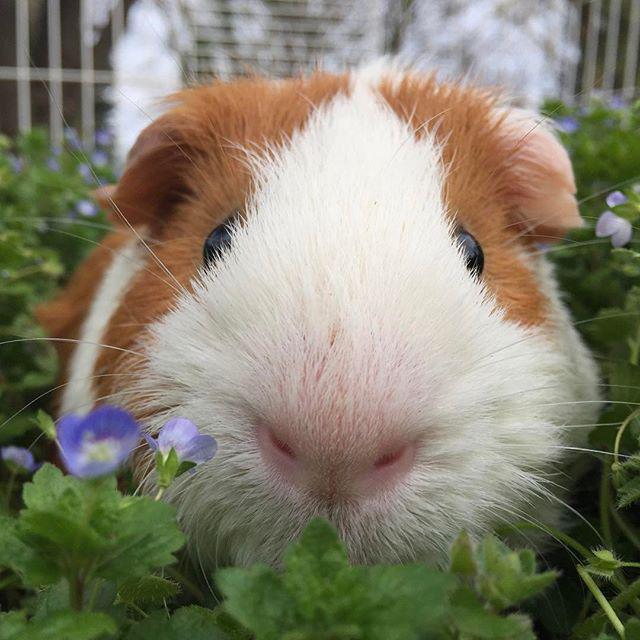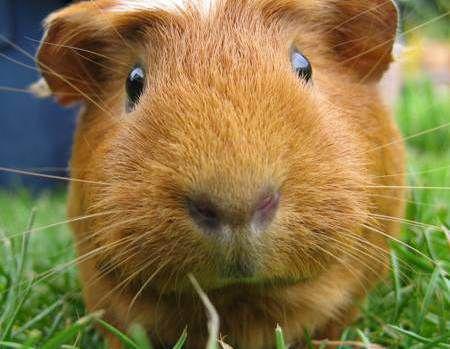The first image is the image on the left, the second image is the image on the right. For the images displayed, is the sentence "One of the animals is brown." factually correct? Answer yes or no. Yes. 